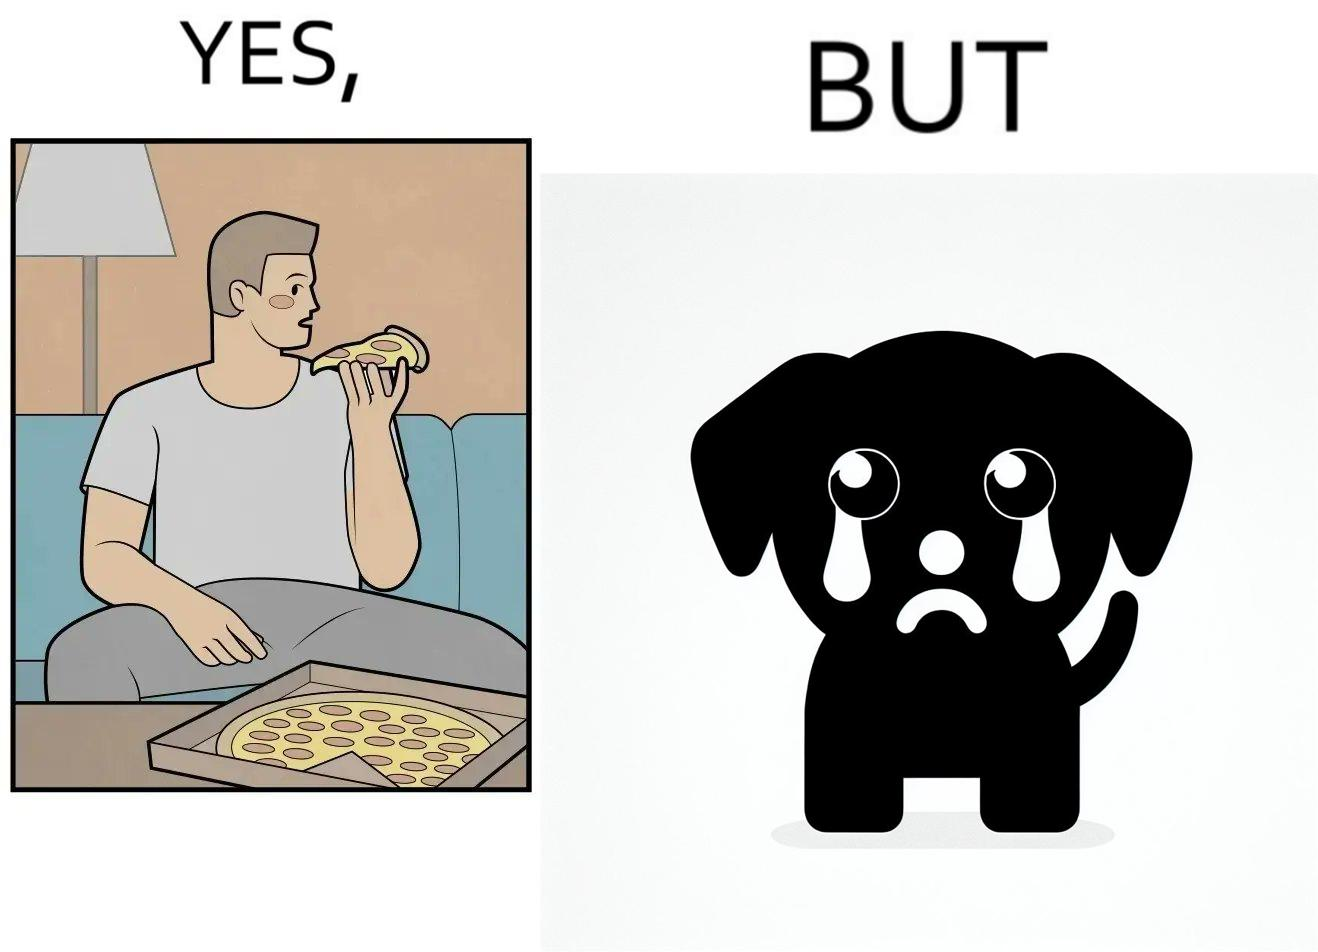What does this image depict? The images are funny since they show how pet owners cannot enjoy any tasty food like pizza without sharing with their pets. The look from the pets makes the owner too guilty if he does not share his food 